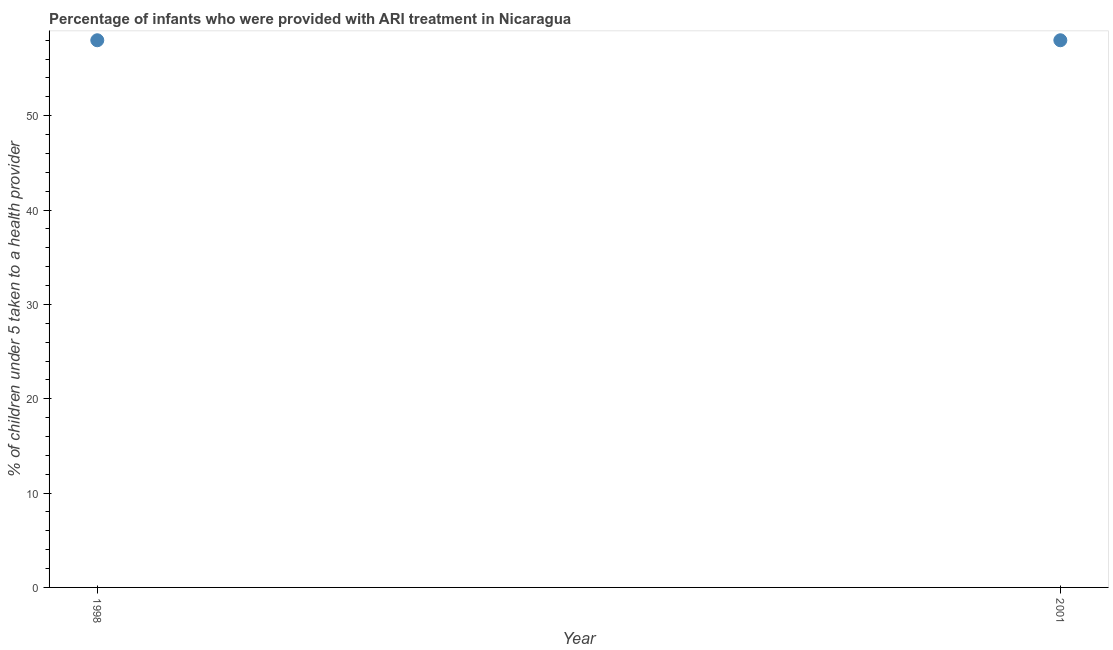What is the percentage of children who were provided with ari treatment in 1998?
Your answer should be compact. 58. Across all years, what is the maximum percentage of children who were provided with ari treatment?
Your response must be concise. 58. Across all years, what is the minimum percentage of children who were provided with ari treatment?
Your answer should be very brief. 58. In which year was the percentage of children who were provided with ari treatment maximum?
Offer a terse response. 1998. What is the sum of the percentage of children who were provided with ari treatment?
Keep it short and to the point. 116. What is the average percentage of children who were provided with ari treatment per year?
Your answer should be very brief. 58. In how many years, is the percentage of children who were provided with ari treatment greater than 10 %?
Your answer should be very brief. 2. Do a majority of the years between 2001 and 1998 (inclusive) have percentage of children who were provided with ari treatment greater than 12 %?
Offer a terse response. No. In how many years, is the percentage of children who were provided with ari treatment greater than the average percentage of children who were provided with ari treatment taken over all years?
Your answer should be compact. 0. Does the graph contain any zero values?
Offer a terse response. No. What is the title of the graph?
Give a very brief answer. Percentage of infants who were provided with ARI treatment in Nicaragua. What is the label or title of the X-axis?
Your answer should be compact. Year. What is the label or title of the Y-axis?
Ensure brevity in your answer.  % of children under 5 taken to a health provider. What is the % of children under 5 taken to a health provider in 1998?
Ensure brevity in your answer.  58. What is the % of children under 5 taken to a health provider in 2001?
Keep it short and to the point. 58. What is the difference between the % of children under 5 taken to a health provider in 1998 and 2001?
Keep it short and to the point. 0. 